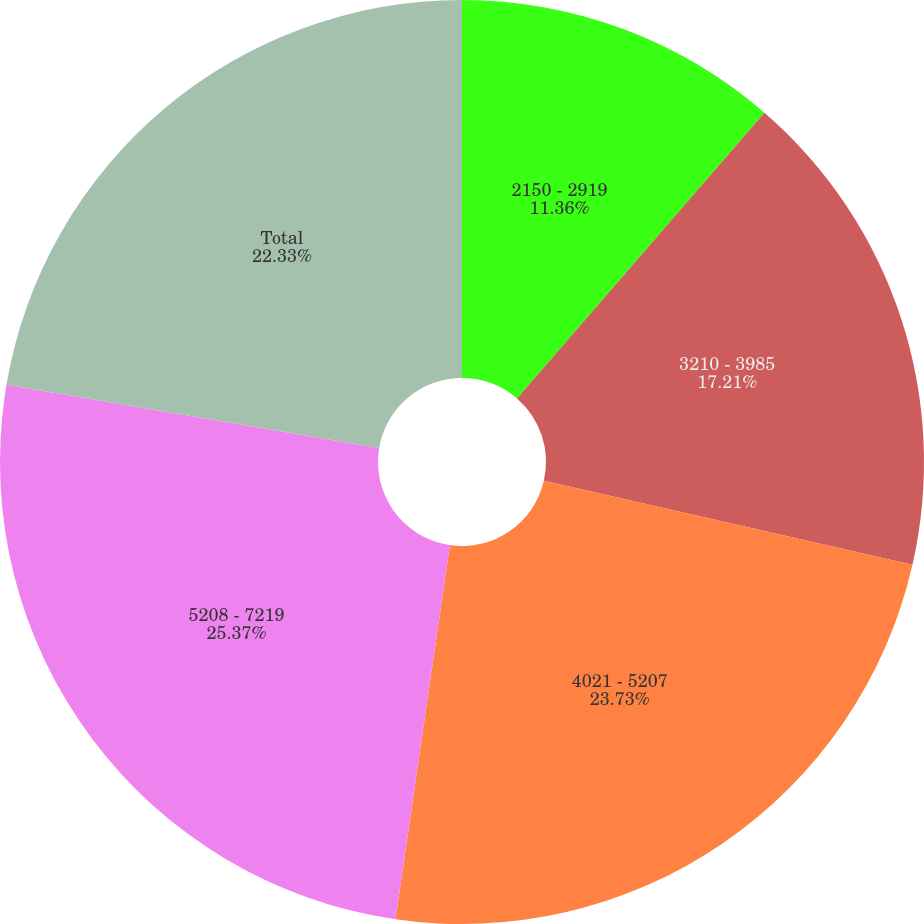Convert chart. <chart><loc_0><loc_0><loc_500><loc_500><pie_chart><fcel>2150 - 2919<fcel>3210 - 3985<fcel>4021 - 5207<fcel>5208 - 7219<fcel>Total<nl><fcel>11.36%<fcel>17.21%<fcel>23.73%<fcel>25.37%<fcel>22.33%<nl></chart> 